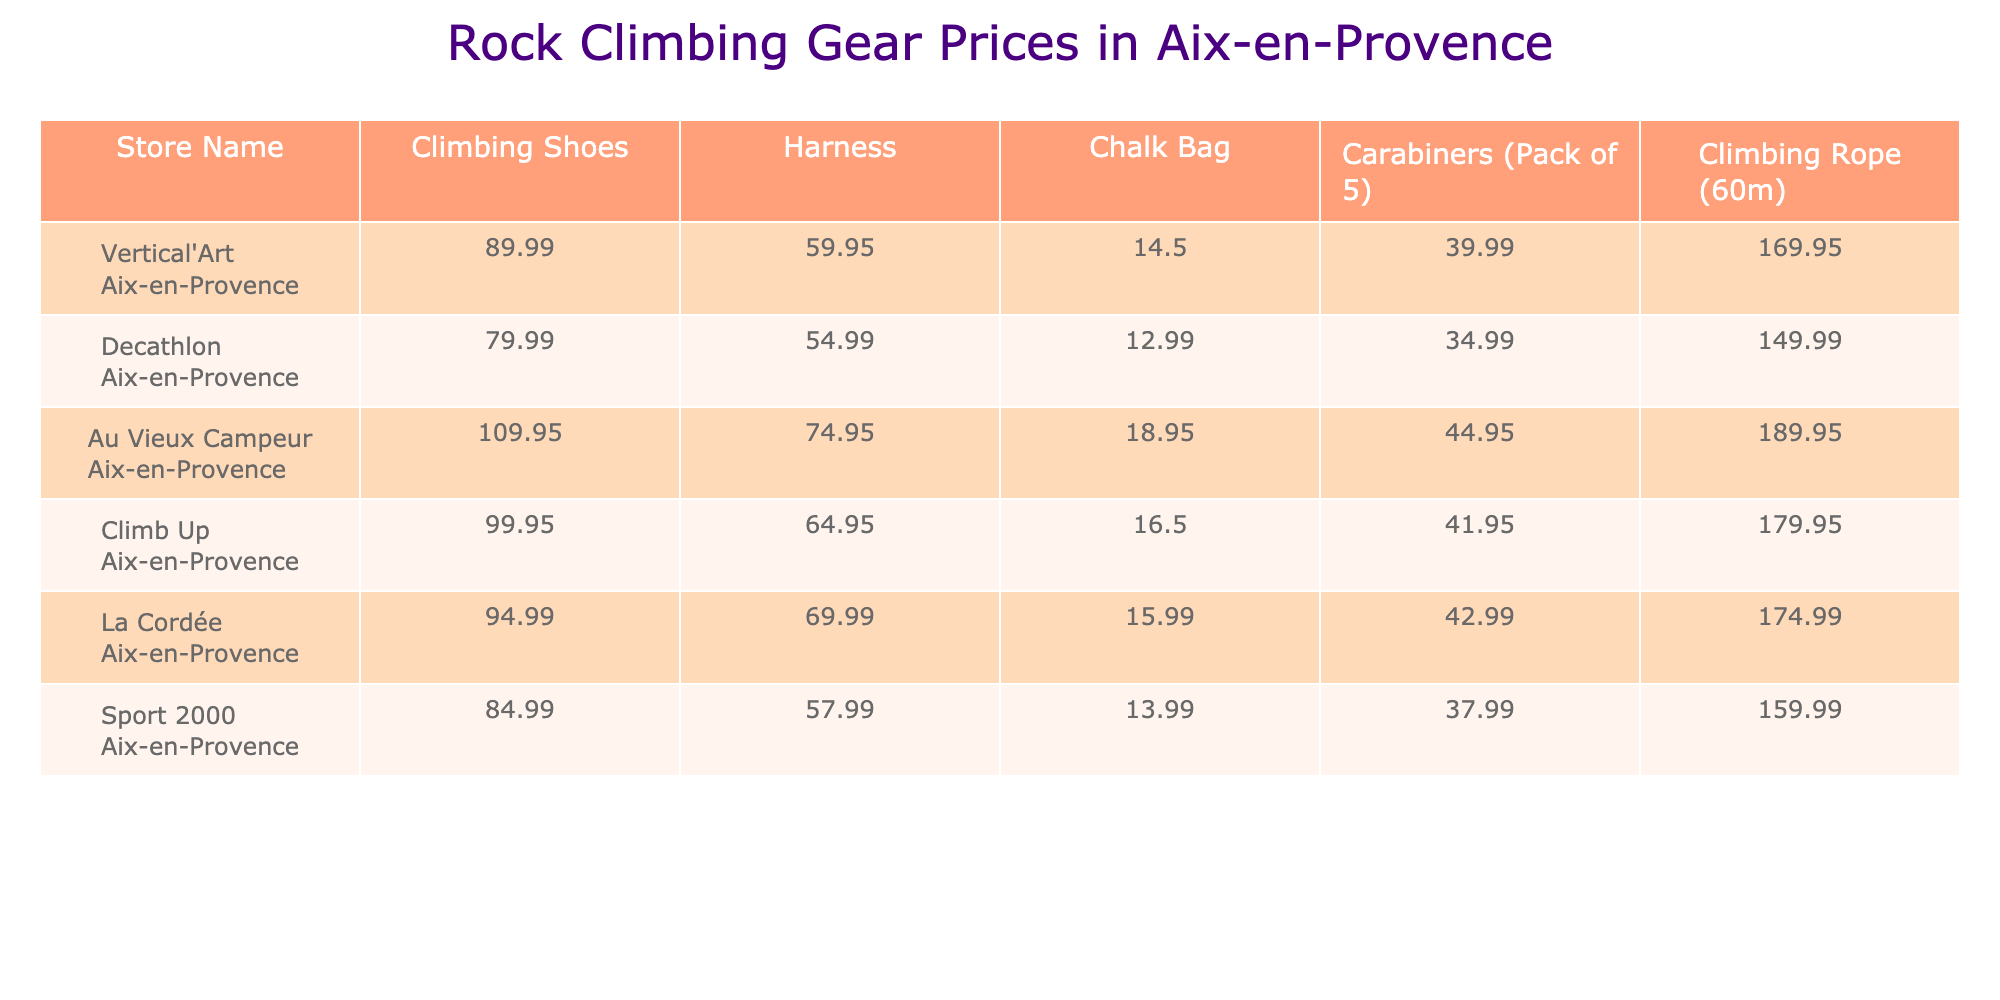What is the price of climbing shoes at Decathlon Aix-en-Provence? The table shows that the price of climbing shoes at Decathlon Aix-en-Provence is listed as 79.99.
Answer: 79.99 Which store offers the cheapest harness? By comparing the prices for harnesses, Decathlon Aix-en-Provence has the lowest price at 54.99.
Answer: Decathlon Aix-en-Provence How much does a chalk bag cost at Au Vieux Campeur Aix-en-Provence? Referring to the table, the price of a chalk bag at Au Vieux Campeur Aix-en-Provence is 18.95.
Answer: 18.95 What is the average price of climbing rope across all stores? The prices of climbing ropes are 169.95, 149.99, 189.95, 179.95, 174.99, and 159.99. Adding them gives 1,024.82; dividing by 6 yields an average of 170.80.
Answer: 170.80 Which store has the highest price for carabiners (pack of 5)? The store with the highest price for carabiners is Au Vieux Campeur Aix-en-Provence with a price of 44.95.
Answer: Au Vieux Campeur Aix-en-Provence Is the price of climbing shoes at Vertical'Art Aix-en-Provence higher than at Climb Up Aix-en-Provence? The price of climbing shoes at Vertical'Art Aix-en-Provence is 89.99, while at Climb Up Aix-en-Provence it is 99.95, which is higher.
Answer: Yes What is the total cost of buying climbing shoes, a harness, and a chalk bag at La Cordée Aix-en-Provence? The cost for climbing shoes, harness, and chalk bag at La Cordée is 94.99 + 69.99 + 15.99 = 180.97.
Answer: 180.97 What is the price difference between climbing ropes at Au Vieux Campeur and Decathlon? The price at Au Vieux Campeur is 189.95 and at Decathlon is 149.99. The difference is 189.95 - 149.99 = 39.96.
Answer: 39.96 Which store provides the most expensive chalk bag? The table indicates that Au Vieux Campeur Aix-en-Provence has the most expensive chalk bag priced at 18.95.
Answer: Au Vieux Campeur Aix-en-Provence Are there any stores where the price of a harness is less than 60? The prices of harnesses are 59.95 (Decathlon), 54.99 (Poifit), 57.99 (Sport 2000), all of which are less than 60. Therefore, yes, there are such stores.
Answer: Yes 